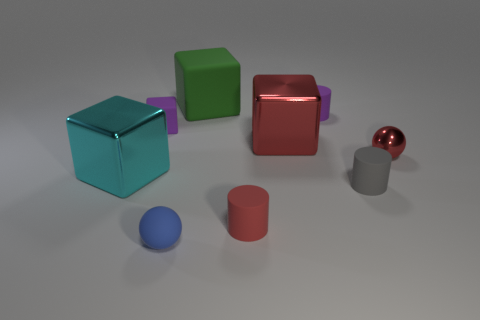Add 1 blue objects. How many objects exist? 10 Subtract all blocks. How many objects are left? 5 Subtract 1 gray cylinders. How many objects are left? 8 Subtract all big matte cubes. Subtract all large purple cylinders. How many objects are left? 8 Add 4 big green objects. How many big green objects are left? 5 Add 1 cyan blocks. How many cyan blocks exist? 2 